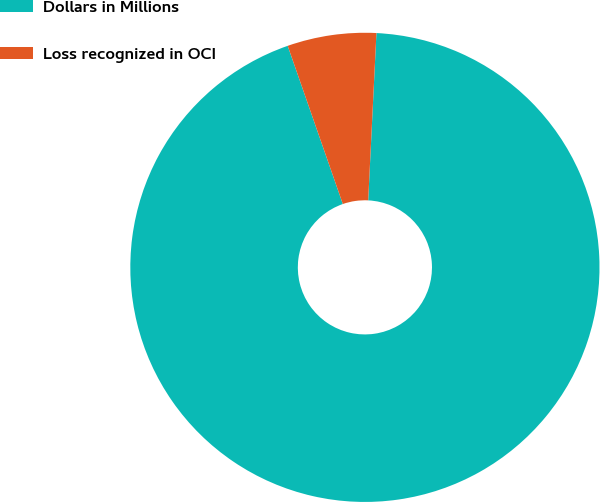Convert chart to OTSL. <chart><loc_0><loc_0><loc_500><loc_500><pie_chart><fcel>Dollars in Millions<fcel>Loss recognized in OCI<nl><fcel>93.88%<fcel>6.12%<nl></chart> 